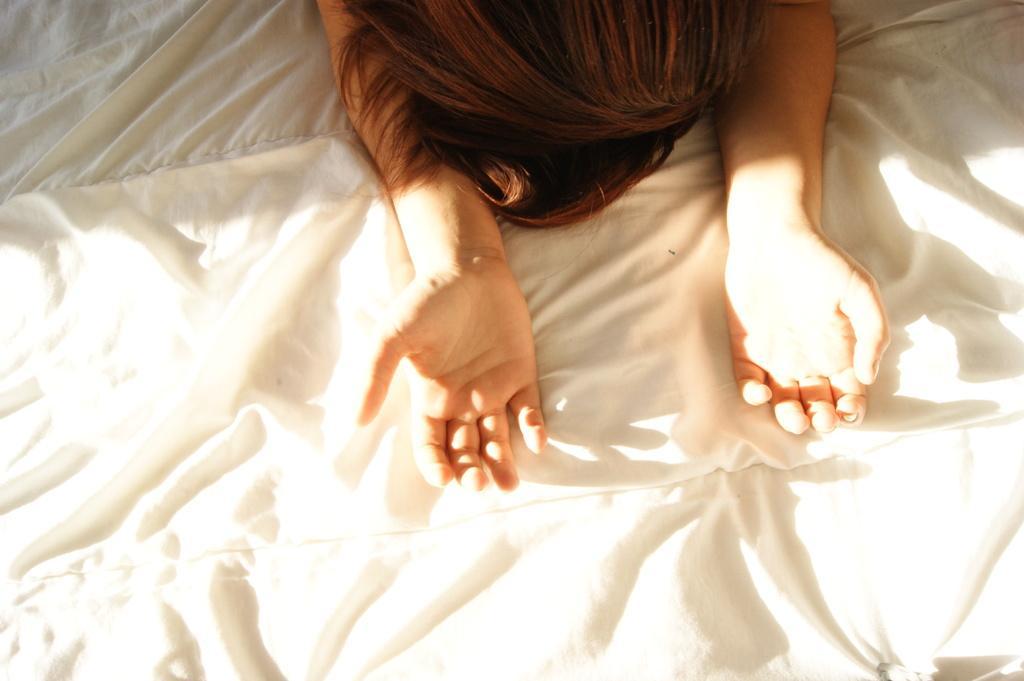Can you describe this image briefly? At the top we can see a person's head and hands. In this picture we can see a white color cloth. 